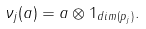<formula> <loc_0><loc_0><loc_500><loc_500>\nu _ { j } ( a ) = a \otimes 1 _ { d i m ( p _ { j } ) } .</formula> 